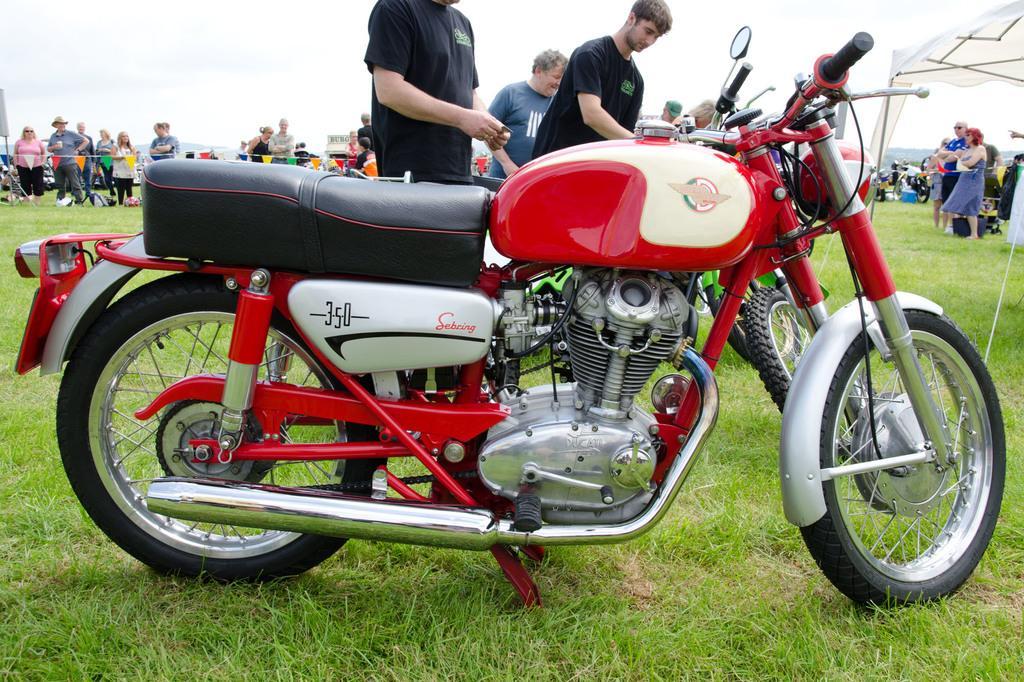Could you give a brief overview of what you see in this image? In this picture I can see there is a a motorcycle parked here, it is in red color and there is grass here on the floor and there are some people here and there are some other people here in the backdrop and the sky is clear. 